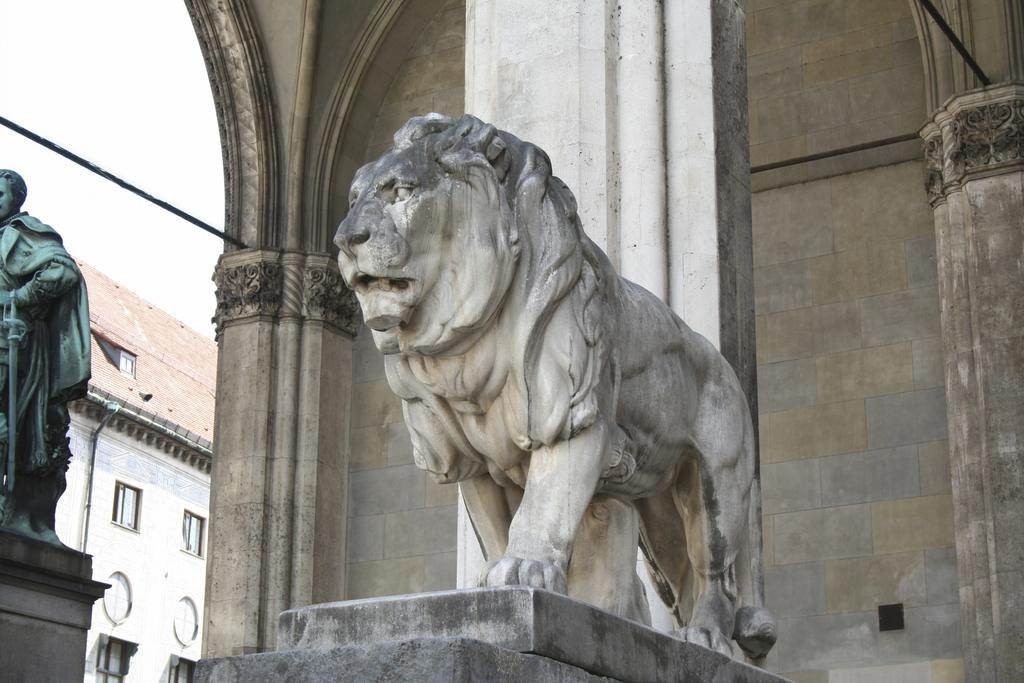What type of animal is depicted in the sculpture on the wall? There is a sculpture of a lion on the wall. What can be seen on the left side of the image? There is a statue on the left side. What is visible in the background of the image? There is a wall in the background. What letter is being written by the lion in the image? There is no letter being written by the lion in the image, as lions do not have the ability to write. 